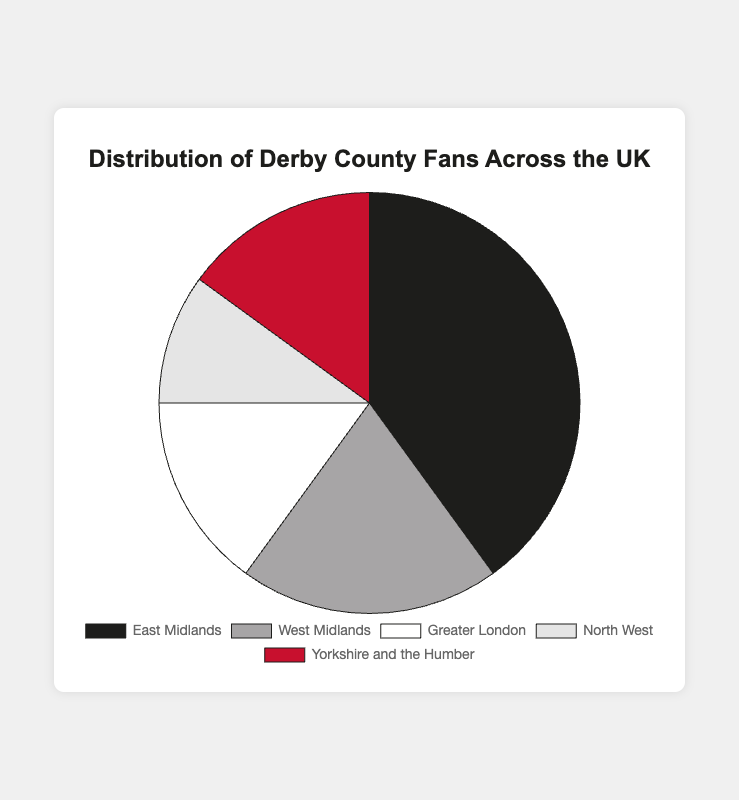What region has the highest percentage of Derby County fans? The East Midlands has the highest percentage. The pie chart shows that 40% of the fans are from this region, which is the largest segment.
Answer: East Midlands Which two regions have an equal percentage of Derby County fans? By observing the pie chart, Greater London and Yorkshire and the Humber both have segments labeled 15%, indicating they have equal percentages of fans.
Answer: Greater London and Yorkshire and the Humber How many regions contribute to 50% of the total Derby County fan base? The East Midlands with 40% and West Midlands with 20%, adding up to 60%, surpass 50%. Thus, only the East Midlands alone does not reach 50%. The answer includes both regions together though only one region covers more than half individually.
Answer: 2 regions Which region has the smallest percentage of Derby County fans? The North West has the smallest segment in the pie chart, marked with 10%.
Answer: North West What's the total percentage of Derby County fans in the West Midlands, Greater London, and the North West combined? Adding the percentages: 20% (West Midlands) + 15% (Greater London) + 10% (North West) equals 45%.
Answer: 45% How much larger, in percentage points, is the East Midlands fan base compared to the West Midlands fan base? Subtract the percentage of West Midlands fans (20%) from that of East Midlands fans (40%): 40% - 20% = 20%.
Answer: 20% What is the sum of the percentages of Derby County fans from regions outside the East Midlands? Add up the percentages of the West Midlands (20%), Greater London (15%), North West (10%), and Yorkshire and the Humber (15%): 20% + 15% + 10% + 15% = 60%.
Answer: 60% If 1000 fans are from Greater London, how many fans approximately are there in total? Given that 15% corresponds to 1000 fans, which represents Greater London, we calculate the total number of fans as follows: 1000 / 0.15 = 6667 fans (approximately).
Answer: 6667 fans 